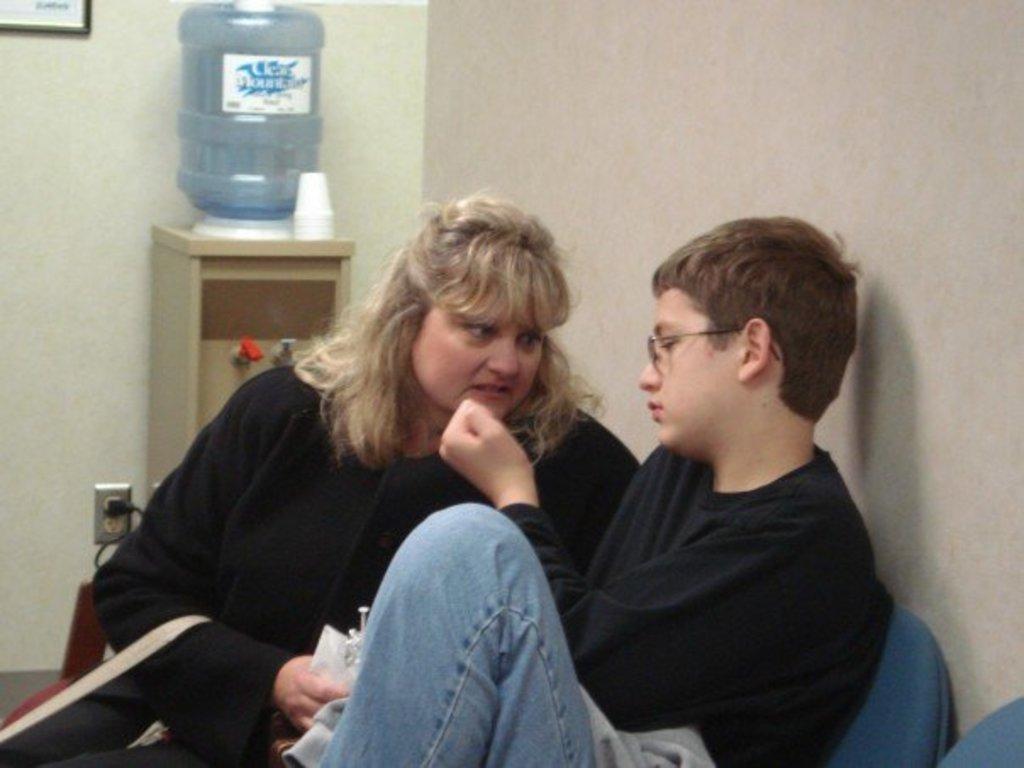How would you summarize this image in a sentence or two? In this image there is a lady and boy sitting on the chairs behind them there is a water filter with glasses on the table and photo frame on the wall. 